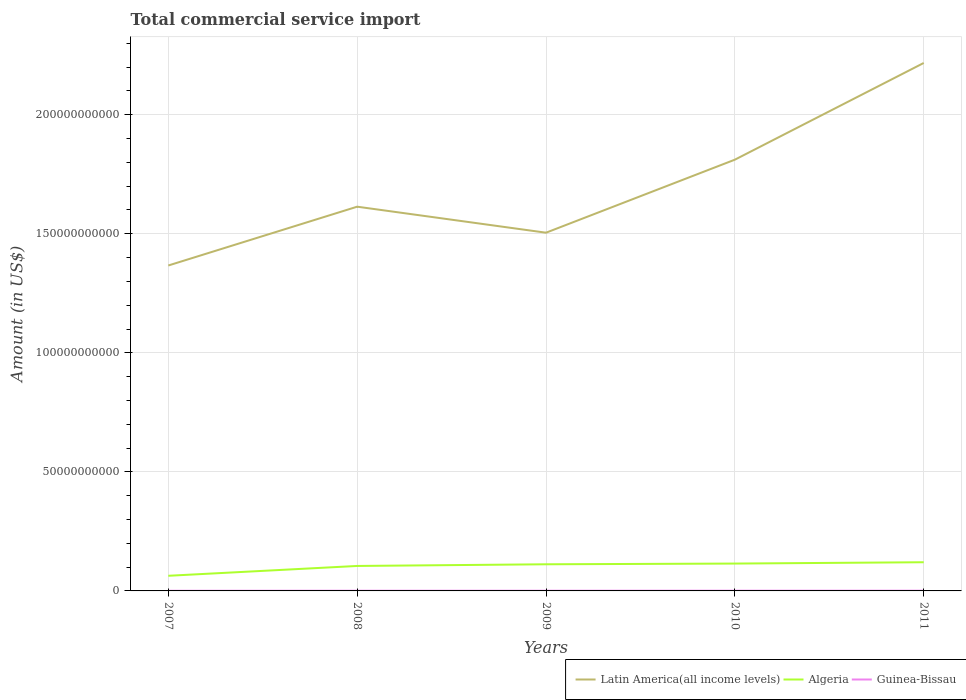Does the line corresponding to Latin America(all income levels) intersect with the line corresponding to Algeria?
Provide a short and direct response. No. Across all years, what is the maximum total commercial service import in Algeria?
Offer a very short reply. 6.36e+09. In which year was the total commercial service import in Guinea-Bissau maximum?
Your response must be concise. 2007. What is the total total commercial service import in Guinea-Bissau in the graph?
Ensure brevity in your answer.  -1.59e+07. What is the difference between the highest and the second highest total commercial service import in Latin America(all income levels)?
Your answer should be compact. 8.51e+1. How many lines are there?
Offer a terse response. 3. How many years are there in the graph?
Offer a very short reply. 5. Are the values on the major ticks of Y-axis written in scientific E-notation?
Offer a terse response. No. What is the title of the graph?
Provide a short and direct response. Total commercial service import. Does "West Bank and Gaza" appear as one of the legend labels in the graph?
Provide a succinct answer. No. What is the Amount (in US$) in Latin America(all income levels) in 2007?
Give a very brief answer. 1.37e+11. What is the Amount (in US$) in Algeria in 2007?
Your answer should be compact. 6.36e+09. What is the Amount (in US$) of Guinea-Bissau in 2007?
Keep it short and to the point. 6.82e+07. What is the Amount (in US$) of Latin America(all income levels) in 2008?
Offer a terse response. 1.61e+11. What is the Amount (in US$) in Algeria in 2008?
Provide a short and direct response. 1.05e+1. What is the Amount (in US$) in Guinea-Bissau in 2008?
Offer a terse response. 8.52e+07. What is the Amount (in US$) in Latin America(all income levels) in 2009?
Ensure brevity in your answer.  1.50e+11. What is the Amount (in US$) in Algeria in 2009?
Offer a terse response. 1.12e+1. What is the Amount (in US$) in Guinea-Bissau in 2009?
Offer a very short reply. 8.46e+07. What is the Amount (in US$) in Latin America(all income levels) in 2010?
Ensure brevity in your answer.  1.81e+11. What is the Amount (in US$) in Algeria in 2010?
Your response must be concise. 1.15e+1. What is the Amount (in US$) of Guinea-Bissau in 2010?
Your response must be concise. 1.01e+08. What is the Amount (in US$) in Latin America(all income levels) in 2011?
Your answer should be very brief. 2.22e+11. What is the Amount (in US$) in Algeria in 2011?
Provide a succinct answer. 1.20e+1. What is the Amount (in US$) of Guinea-Bissau in 2011?
Offer a terse response. 9.96e+07. Across all years, what is the maximum Amount (in US$) in Latin America(all income levels)?
Give a very brief answer. 2.22e+11. Across all years, what is the maximum Amount (in US$) in Algeria?
Your response must be concise. 1.20e+1. Across all years, what is the maximum Amount (in US$) of Guinea-Bissau?
Your response must be concise. 1.01e+08. Across all years, what is the minimum Amount (in US$) of Latin America(all income levels)?
Make the answer very short. 1.37e+11. Across all years, what is the minimum Amount (in US$) of Algeria?
Ensure brevity in your answer.  6.36e+09. Across all years, what is the minimum Amount (in US$) of Guinea-Bissau?
Your answer should be compact. 6.82e+07. What is the total Amount (in US$) of Latin America(all income levels) in the graph?
Your answer should be very brief. 8.51e+11. What is the total Amount (in US$) of Algeria in the graph?
Keep it short and to the point. 5.16e+1. What is the total Amount (in US$) in Guinea-Bissau in the graph?
Offer a terse response. 4.38e+08. What is the difference between the Amount (in US$) in Latin America(all income levels) in 2007 and that in 2008?
Ensure brevity in your answer.  -2.47e+1. What is the difference between the Amount (in US$) in Algeria in 2007 and that in 2008?
Keep it short and to the point. -4.13e+09. What is the difference between the Amount (in US$) of Guinea-Bissau in 2007 and that in 2008?
Make the answer very short. -1.69e+07. What is the difference between the Amount (in US$) in Latin America(all income levels) in 2007 and that in 2009?
Offer a very short reply. -1.38e+1. What is the difference between the Amount (in US$) in Algeria in 2007 and that in 2009?
Ensure brevity in your answer.  -4.83e+09. What is the difference between the Amount (in US$) in Guinea-Bissau in 2007 and that in 2009?
Make the answer very short. -1.63e+07. What is the difference between the Amount (in US$) in Latin America(all income levels) in 2007 and that in 2010?
Ensure brevity in your answer.  -4.44e+1. What is the difference between the Amount (in US$) of Algeria in 2007 and that in 2010?
Ensure brevity in your answer.  -5.13e+09. What is the difference between the Amount (in US$) of Guinea-Bissau in 2007 and that in 2010?
Your answer should be very brief. -3.23e+07. What is the difference between the Amount (in US$) in Latin America(all income levels) in 2007 and that in 2011?
Provide a short and direct response. -8.51e+1. What is the difference between the Amount (in US$) in Algeria in 2007 and that in 2011?
Keep it short and to the point. -5.69e+09. What is the difference between the Amount (in US$) in Guinea-Bissau in 2007 and that in 2011?
Your answer should be very brief. -3.13e+07. What is the difference between the Amount (in US$) of Latin America(all income levels) in 2008 and that in 2009?
Provide a short and direct response. 1.09e+1. What is the difference between the Amount (in US$) in Algeria in 2008 and that in 2009?
Offer a terse response. -7.03e+08. What is the difference between the Amount (in US$) of Guinea-Bissau in 2008 and that in 2009?
Ensure brevity in your answer.  6.30e+05. What is the difference between the Amount (in US$) in Latin America(all income levels) in 2008 and that in 2010?
Your response must be concise. -1.97e+1. What is the difference between the Amount (in US$) in Algeria in 2008 and that in 2010?
Provide a succinct answer. -1.01e+09. What is the difference between the Amount (in US$) in Guinea-Bissau in 2008 and that in 2010?
Give a very brief answer. -1.53e+07. What is the difference between the Amount (in US$) in Latin America(all income levels) in 2008 and that in 2011?
Make the answer very short. -6.04e+1. What is the difference between the Amount (in US$) of Algeria in 2008 and that in 2011?
Your response must be concise. -1.56e+09. What is the difference between the Amount (in US$) in Guinea-Bissau in 2008 and that in 2011?
Keep it short and to the point. -1.44e+07. What is the difference between the Amount (in US$) in Latin America(all income levels) in 2009 and that in 2010?
Your answer should be very brief. -3.07e+1. What is the difference between the Amount (in US$) of Algeria in 2009 and that in 2010?
Your answer should be very brief. -3.05e+08. What is the difference between the Amount (in US$) of Guinea-Bissau in 2009 and that in 2010?
Make the answer very short. -1.59e+07. What is the difference between the Amount (in US$) of Latin America(all income levels) in 2009 and that in 2011?
Provide a short and direct response. -7.13e+1. What is the difference between the Amount (in US$) of Algeria in 2009 and that in 2011?
Your response must be concise. -8.60e+08. What is the difference between the Amount (in US$) in Guinea-Bissau in 2009 and that in 2011?
Make the answer very short. -1.50e+07. What is the difference between the Amount (in US$) in Latin America(all income levels) in 2010 and that in 2011?
Provide a short and direct response. -4.06e+1. What is the difference between the Amount (in US$) in Algeria in 2010 and that in 2011?
Keep it short and to the point. -5.55e+08. What is the difference between the Amount (in US$) in Guinea-Bissau in 2010 and that in 2011?
Provide a short and direct response. 9.31e+05. What is the difference between the Amount (in US$) in Latin America(all income levels) in 2007 and the Amount (in US$) in Algeria in 2008?
Make the answer very short. 1.26e+11. What is the difference between the Amount (in US$) of Latin America(all income levels) in 2007 and the Amount (in US$) of Guinea-Bissau in 2008?
Provide a short and direct response. 1.37e+11. What is the difference between the Amount (in US$) of Algeria in 2007 and the Amount (in US$) of Guinea-Bissau in 2008?
Your answer should be compact. 6.27e+09. What is the difference between the Amount (in US$) of Latin America(all income levels) in 2007 and the Amount (in US$) of Algeria in 2009?
Provide a short and direct response. 1.25e+11. What is the difference between the Amount (in US$) in Latin America(all income levels) in 2007 and the Amount (in US$) in Guinea-Bissau in 2009?
Provide a short and direct response. 1.37e+11. What is the difference between the Amount (in US$) in Algeria in 2007 and the Amount (in US$) in Guinea-Bissau in 2009?
Give a very brief answer. 6.27e+09. What is the difference between the Amount (in US$) in Latin America(all income levels) in 2007 and the Amount (in US$) in Algeria in 2010?
Ensure brevity in your answer.  1.25e+11. What is the difference between the Amount (in US$) of Latin America(all income levels) in 2007 and the Amount (in US$) of Guinea-Bissau in 2010?
Give a very brief answer. 1.37e+11. What is the difference between the Amount (in US$) in Algeria in 2007 and the Amount (in US$) in Guinea-Bissau in 2010?
Make the answer very short. 6.26e+09. What is the difference between the Amount (in US$) in Latin America(all income levels) in 2007 and the Amount (in US$) in Algeria in 2011?
Offer a very short reply. 1.25e+11. What is the difference between the Amount (in US$) in Latin America(all income levels) in 2007 and the Amount (in US$) in Guinea-Bissau in 2011?
Offer a terse response. 1.37e+11. What is the difference between the Amount (in US$) in Algeria in 2007 and the Amount (in US$) in Guinea-Bissau in 2011?
Make the answer very short. 6.26e+09. What is the difference between the Amount (in US$) of Latin America(all income levels) in 2008 and the Amount (in US$) of Algeria in 2009?
Offer a very short reply. 1.50e+11. What is the difference between the Amount (in US$) of Latin America(all income levels) in 2008 and the Amount (in US$) of Guinea-Bissau in 2009?
Your response must be concise. 1.61e+11. What is the difference between the Amount (in US$) in Algeria in 2008 and the Amount (in US$) in Guinea-Bissau in 2009?
Give a very brief answer. 1.04e+1. What is the difference between the Amount (in US$) of Latin America(all income levels) in 2008 and the Amount (in US$) of Algeria in 2010?
Your answer should be very brief. 1.50e+11. What is the difference between the Amount (in US$) in Latin America(all income levels) in 2008 and the Amount (in US$) in Guinea-Bissau in 2010?
Your response must be concise. 1.61e+11. What is the difference between the Amount (in US$) of Algeria in 2008 and the Amount (in US$) of Guinea-Bissau in 2010?
Give a very brief answer. 1.04e+1. What is the difference between the Amount (in US$) of Latin America(all income levels) in 2008 and the Amount (in US$) of Algeria in 2011?
Keep it short and to the point. 1.49e+11. What is the difference between the Amount (in US$) in Latin America(all income levels) in 2008 and the Amount (in US$) in Guinea-Bissau in 2011?
Your response must be concise. 1.61e+11. What is the difference between the Amount (in US$) in Algeria in 2008 and the Amount (in US$) in Guinea-Bissau in 2011?
Your answer should be compact. 1.04e+1. What is the difference between the Amount (in US$) in Latin America(all income levels) in 2009 and the Amount (in US$) in Algeria in 2010?
Offer a very short reply. 1.39e+11. What is the difference between the Amount (in US$) of Latin America(all income levels) in 2009 and the Amount (in US$) of Guinea-Bissau in 2010?
Provide a short and direct response. 1.50e+11. What is the difference between the Amount (in US$) of Algeria in 2009 and the Amount (in US$) of Guinea-Bissau in 2010?
Your response must be concise. 1.11e+1. What is the difference between the Amount (in US$) in Latin America(all income levels) in 2009 and the Amount (in US$) in Algeria in 2011?
Give a very brief answer. 1.38e+11. What is the difference between the Amount (in US$) in Latin America(all income levels) in 2009 and the Amount (in US$) in Guinea-Bissau in 2011?
Make the answer very short. 1.50e+11. What is the difference between the Amount (in US$) of Algeria in 2009 and the Amount (in US$) of Guinea-Bissau in 2011?
Your response must be concise. 1.11e+1. What is the difference between the Amount (in US$) of Latin America(all income levels) in 2010 and the Amount (in US$) of Algeria in 2011?
Your response must be concise. 1.69e+11. What is the difference between the Amount (in US$) of Latin America(all income levels) in 2010 and the Amount (in US$) of Guinea-Bissau in 2011?
Offer a very short reply. 1.81e+11. What is the difference between the Amount (in US$) in Algeria in 2010 and the Amount (in US$) in Guinea-Bissau in 2011?
Provide a short and direct response. 1.14e+1. What is the average Amount (in US$) of Latin America(all income levels) per year?
Offer a terse response. 1.70e+11. What is the average Amount (in US$) of Algeria per year?
Your answer should be compact. 1.03e+1. What is the average Amount (in US$) of Guinea-Bissau per year?
Keep it short and to the point. 8.76e+07. In the year 2007, what is the difference between the Amount (in US$) in Latin America(all income levels) and Amount (in US$) in Algeria?
Offer a terse response. 1.30e+11. In the year 2007, what is the difference between the Amount (in US$) of Latin America(all income levels) and Amount (in US$) of Guinea-Bissau?
Offer a very short reply. 1.37e+11. In the year 2007, what is the difference between the Amount (in US$) of Algeria and Amount (in US$) of Guinea-Bissau?
Keep it short and to the point. 6.29e+09. In the year 2008, what is the difference between the Amount (in US$) of Latin America(all income levels) and Amount (in US$) of Algeria?
Your answer should be compact. 1.51e+11. In the year 2008, what is the difference between the Amount (in US$) in Latin America(all income levels) and Amount (in US$) in Guinea-Bissau?
Make the answer very short. 1.61e+11. In the year 2008, what is the difference between the Amount (in US$) of Algeria and Amount (in US$) of Guinea-Bissau?
Provide a short and direct response. 1.04e+1. In the year 2009, what is the difference between the Amount (in US$) of Latin America(all income levels) and Amount (in US$) of Algeria?
Ensure brevity in your answer.  1.39e+11. In the year 2009, what is the difference between the Amount (in US$) in Latin America(all income levels) and Amount (in US$) in Guinea-Bissau?
Provide a short and direct response. 1.50e+11. In the year 2009, what is the difference between the Amount (in US$) in Algeria and Amount (in US$) in Guinea-Bissau?
Keep it short and to the point. 1.11e+1. In the year 2010, what is the difference between the Amount (in US$) of Latin America(all income levels) and Amount (in US$) of Algeria?
Provide a succinct answer. 1.70e+11. In the year 2010, what is the difference between the Amount (in US$) in Latin America(all income levels) and Amount (in US$) in Guinea-Bissau?
Provide a short and direct response. 1.81e+11. In the year 2010, what is the difference between the Amount (in US$) of Algeria and Amount (in US$) of Guinea-Bissau?
Your answer should be compact. 1.14e+1. In the year 2011, what is the difference between the Amount (in US$) of Latin America(all income levels) and Amount (in US$) of Algeria?
Keep it short and to the point. 2.10e+11. In the year 2011, what is the difference between the Amount (in US$) in Latin America(all income levels) and Amount (in US$) in Guinea-Bissau?
Give a very brief answer. 2.22e+11. In the year 2011, what is the difference between the Amount (in US$) in Algeria and Amount (in US$) in Guinea-Bissau?
Offer a terse response. 1.19e+1. What is the ratio of the Amount (in US$) in Latin America(all income levels) in 2007 to that in 2008?
Your answer should be compact. 0.85. What is the ratio of the Amount (in US$) in Algeria in 2007 to that in 2008?
Your answer should be very brief. 0.61. What is the ratio of the Amount (in US$) in Guinea-Bissau in 2007 to that in 2008?
Offer a terse response. 0.8. What is the ratio of the Amount (in US$) of Latin America(all income levels) in 2007 to that in 2009?
Offer a very short reply. 0.91. What is the ratio of the Amount (in US$) of Algeria in 2007 to that in 2009?
Offer a very short reply. 0.57. What is the ratio of the Amount (in US$) of Guinea-Bissau in 2007 to that in 2009?
Make the answer very short. 0.81. What is the ratio of the Amount (in US$) in Latin America(all income levels) in 2007 to that in 2010?
Your answer should be very brief. 0.75. What is the ratio of the Amount (in US$) in Algeria in 2007 to that in 2010?
Your answer should be compact. 0.55. What is the ratio of the Amount (in US$) of Guinea-Bissau in 2007 to that in 2010?
Provide a succinct answer. 0.68. What is the ratio of the Amount (in US$) in Latin America(all income levels) in 2007 to that in 2011?
Give a very brief answer. 0.62. What is the ratio of the Amount (in US$) of Algeria in 2007 to that in 2011?
Your response must be concise. 0.53. What is the ratio of the Amount (in US$) in Guinea-Bissau in 2007 to that in 2011?
Give a very brief answer. 0.69. What is the ratio of the Amount (in US$) of Latin America(all income levels) in 2008 to that in 2009?
Ensure brevity in your answer.  1.07. What is the ratio of the Amount (in US$) of Algeria in 2008 to that in 2009?
Offer a very short reply. 0.94. What is the ratio of the Amount (in US$) of Guinea-Bissau in 2008 to that in 2009?
Provide a succinct answer. 1.01. What is the ratio of the Amount (in US$) in Latin America(all income levels) in 2008 to that in 2010?
Offer a terse response. 0.89. What is the ratio of the Amount (in US$) of Algeria in 2008 to that in 2010?
Provide a short and direct response. 0.91. What is the ratio of the Amount (in US$) in Guinea-Bissau in 2008 to that in 2010?
Provide a succinct answer. 0.85. What is the ratio of the Amount (in US$) in Latin America(all income levels) in 2008 to that in 2011?
Make the answer very short. 0.73. What is the ratio of the Amount (in US$) of Algeria in 2008 to that in 2011?
Provide a short and direct response. 0.87. What is the ratio of the Amount (in US$) of Guinea-Bissau in 2008 to that in 2011?
Provide a short and direct response. 0.86. What is the ratio of the Amount (in US$) in Latin America(all income levels) in 2009 to that in 2010?
Offer a very short reply. 0.83. What is the ratio of the Amount (in US$) of Algeria in 2009 to that in 2010?
Provide a succinct answer. 0.97. What is the ratio of the Amount (in US$) in Guinea-Bissau in 2009 to that in 2010?
Make the answer very short. 0.84. What is the ratio of the Amount (in US$) of Latin America(all income levels) in 2009 to that in 2011?
Your response must be concise. 0.68. What is the ratio of the Amount (in US$) in Algeria in 2009 to that in 2011?
Offer a very short reply. 0.93. What is the ratio of the Amount (in US$) of Guinea-Bissau in 2009 to that in 2011?
Offer a terse response. 0.85. What is the ratio of the Amount (in US$) of Latin America(all income levels) in 2010 to that in 2011?
Your response must be concise. 0.82. What is the ratio of the Amount (in US$) in Algeria in 2010 to that in 2011?
Keep it short and to the point. 0.95. What is the ratio of the Amount (in US$) in Guinea-Bissau in 2010 to that in 2011?
Provide a short and direct response. 1.01. What is the difference between the highest and the second highest Amount (in US$) in Latin America(all income levels)?
Give a very brief answer. 4.06e+1. What is the difference between the highest and the second highest Amount (in US$) of Algeria?
Keep it short and to the point. 5.55e+08. What is the difference between the highest and the second highest Amount (in US$) of Guinea-Bissau?
Your response must be concise. 9.31e+05. What is the difference between the highest and the lowest Amount (in US$) in Latin America(all income levels)?
Your response must be concise. 8.51e+1. What is the difference between the highest and the lowest Amount (in US$) in Algeria?
Your response must be concise. 5.69e+09. What is the difference between the highest and the lowest Amount (in US$) in Guinea-Bissau?
Give a very brief answer. 3.23e+07. 